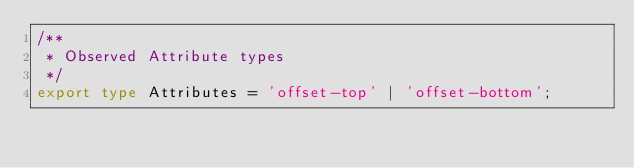<code> <loc_0><loc_0><loc_500><loc_500><_TypeScript_>/**
 * Observed Attribute types
 */
export type Attributes = 'offset-top' | 'offset-bottom';
</code> 